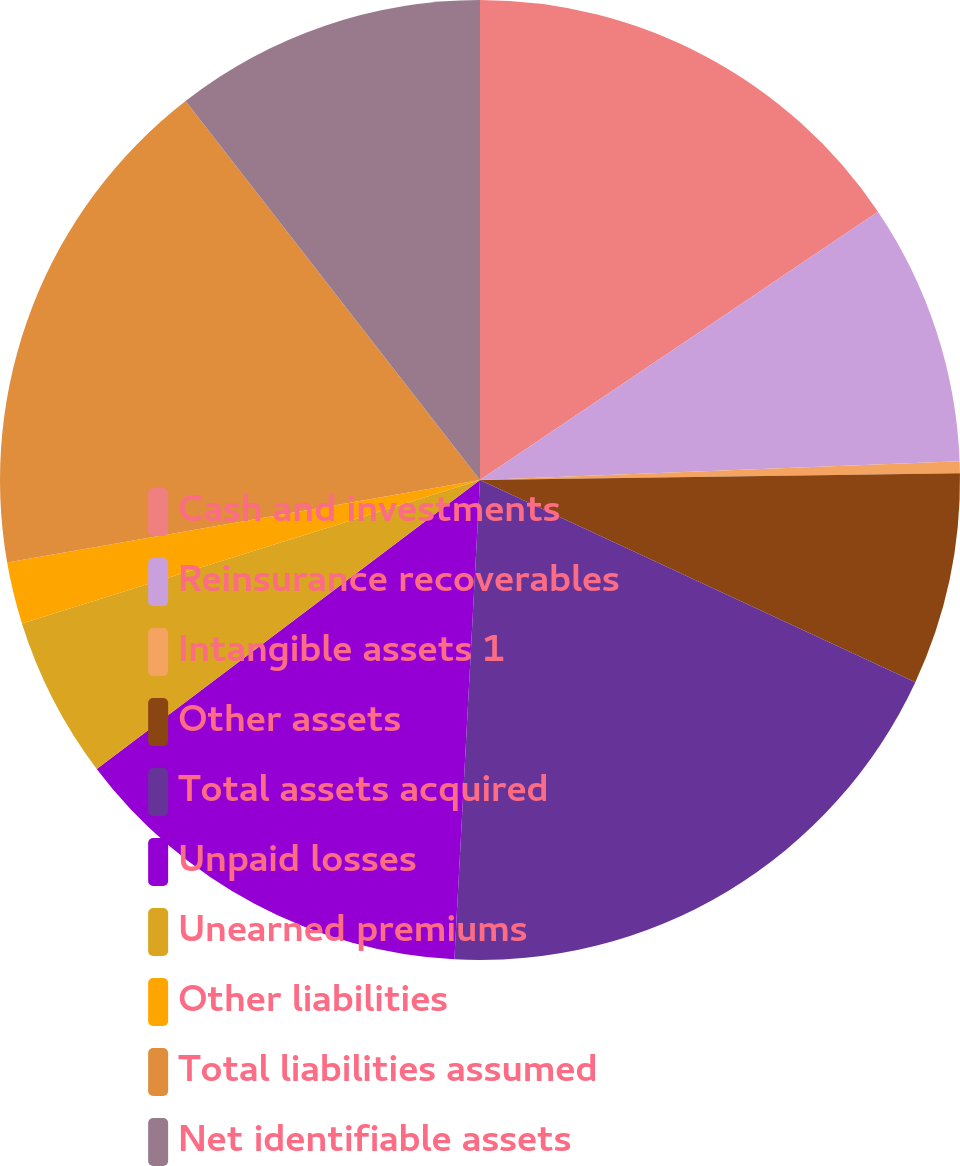<chart> <loc_0><loc_0><loc_500><loc_500><pie_chart><fcel>Cash and investments<fcel>Reinsurance recoverables<fcel>Intangible assets 1<fcel>Other assets<fcel>Total assets acquired<fcel>Unpaid losses<fcel>Unearned premiums<fcel>Other liabilities<fcel>Total liabilities assumed<fcel>Net identifiable assets<nl><fcel>15.56%<fcel>8.82%<fcel>0.4%<fcel>7.14%<fcel>18.93%<fcel>13.87%<fcel>5.45%<fcel>2.08%<fcel>17.24%<fcel>10.51%<nl></chart> 